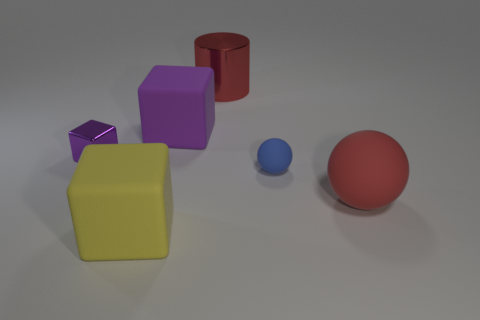What is the shape of the red object in front of the big matte block that is behind the yellow rubber thing?
Provide a succinct answer. Sphere. There is a large ball that is the same color as the cylinder; what material is it?
Make the answer very short. Rubber. The other large sphere that is made of the same material as the blue sphere is what color?
Keep it short and to the point. Red. Is the color of the shiny thing in front of the big metallic thing the same as the large cube right of the yellow matte block?
Offer a terse response. Yes. Are there more large red things in front of the tiny matte ball than purple metal cubes behind the large cylinder?
Provide a short and direct response. Yes. There is another thing that is the same shape as the blue rubber thing; what is its color?
Keep it short and to the point. Red. Are there any other things that are the same shape as the tiny purple thing?
Make the answer very short. Yes. Does the big yellow thing have the same shape as the shiny object that is right of the yellow matte cube?
Your answer should be very brief. No. How many other things are there of the same material as the yellow thing?
Your answer should be compact. 3. There is a metal cylinder; does it have the same color as the big object on the right side of the red metallic object?
Keep it short and to the point. Yes. 